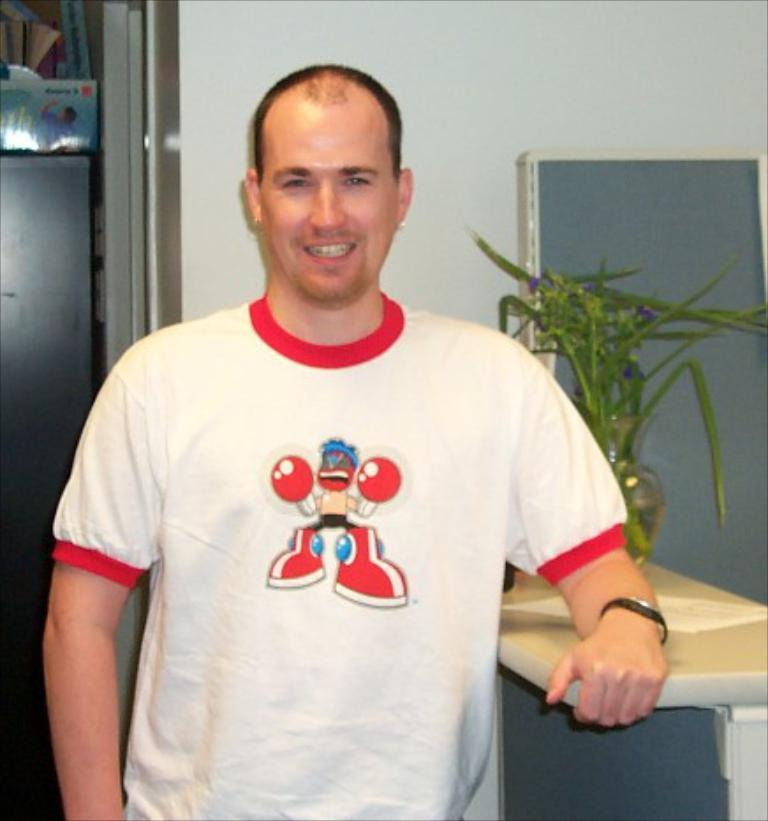Who or what is present in the image? There is a person in the image. What is the person's facial expression? The person is smiling. What can be seen in the background of the image? There is a wall, a pot with a plant, and some other objects in the background of the image. What historical event is being referenced in the image? There is no historical event being referenced in the image; it simply features a person smiling with a background containing a wall, a pot with a plant, and other objects. 